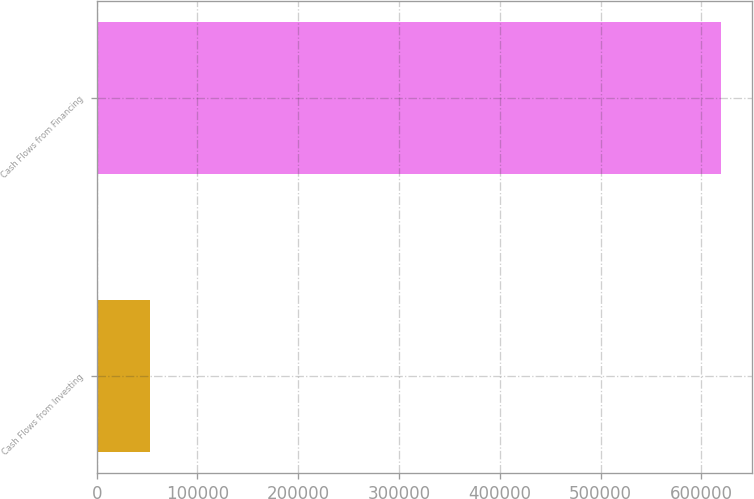Convert chart to OTSL. <chart><loc_0><loc_0><loc_500><loc_500><bar_chart><fcel>Cash Flows from Investing<fcel>Cash Flows from Financing<nl><fcel>53103<fcel>619704<nl></chart> 